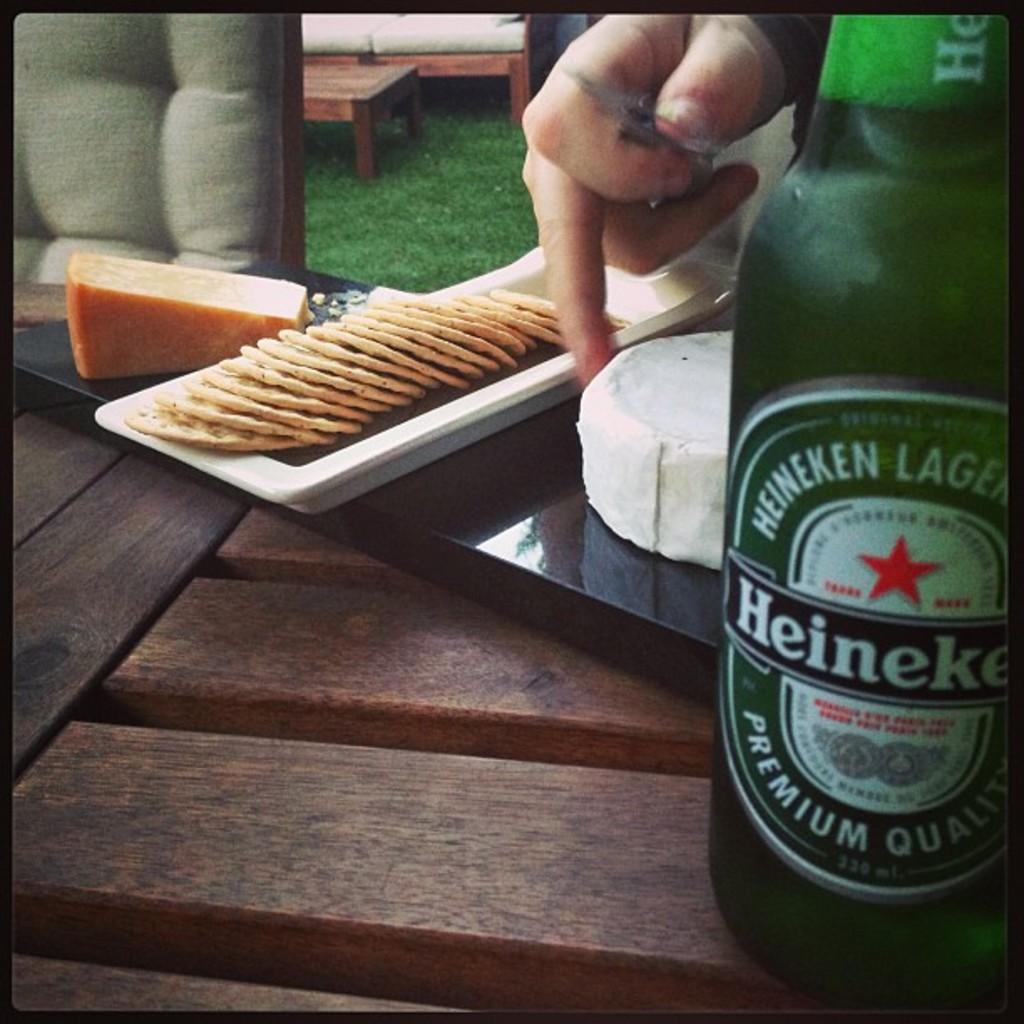What kind of beer is heineken?
Your answer should be compact. Lager. What brand of beer is shown?
Make the answer very short. Heineken. 